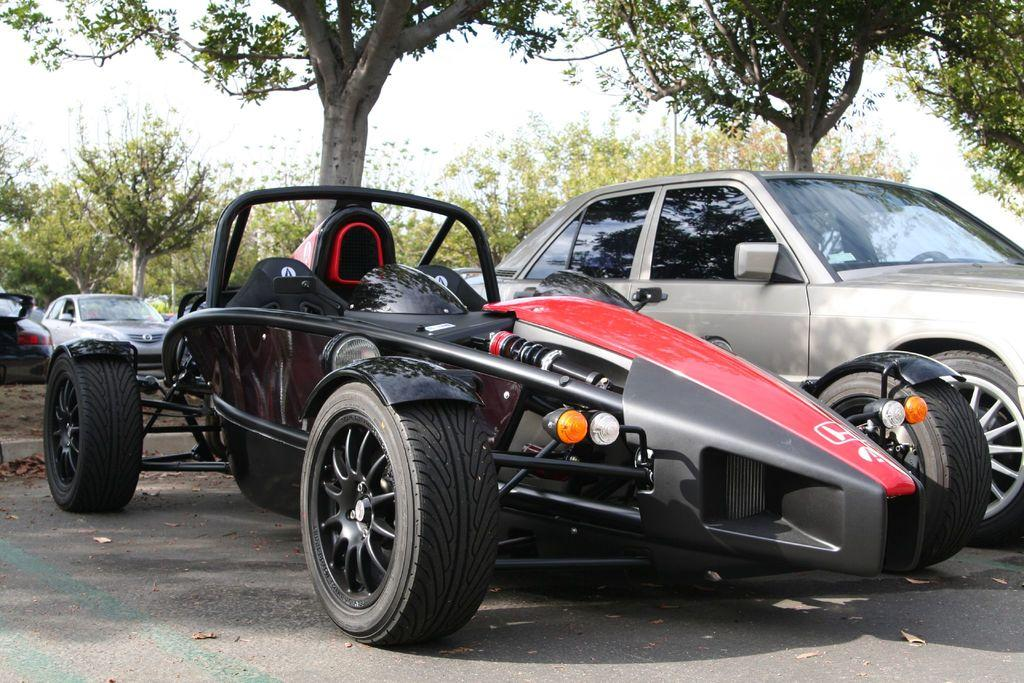How many cars are present in the image? There are two cars in the image. Can you describe one of the cars in the image? One of the cars resembles an F1 racing car. What can be seen in the background of the image? There are trees and the sky visible in the background of the image. What type of attraction can be seen in the image? There is no attraction present in the image; it features two cars and a background with trees and the sky. What smell is associated with the image? There is no specific smell associated with the image, as it is a visual representation of two cars and the surrounding environment. 